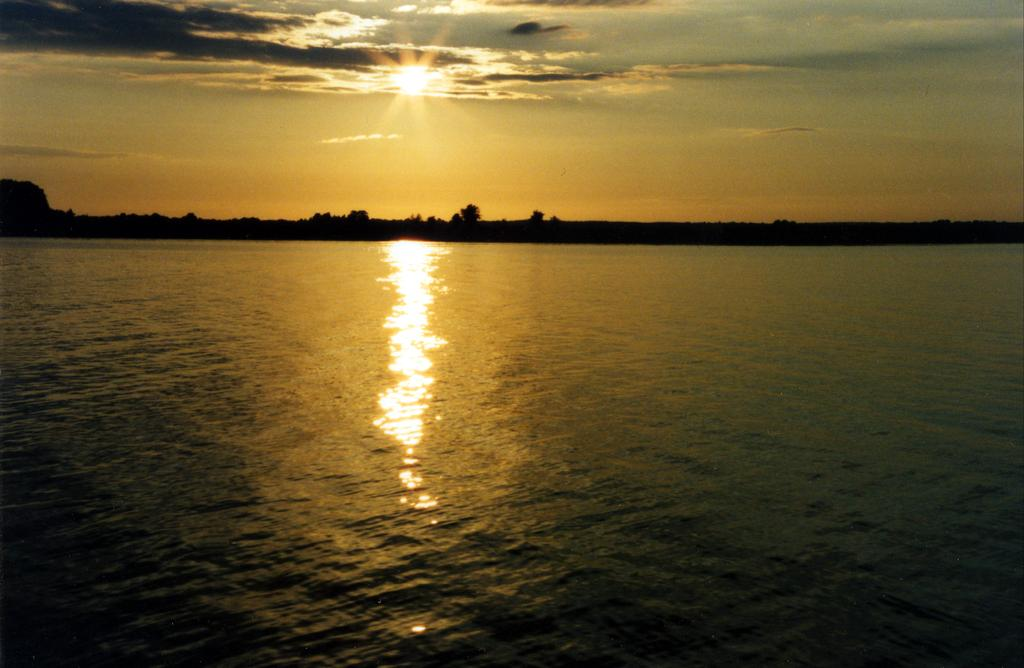What is the primary element visible in the image? There is water in the image. What can be seen in the background of the image? There are trees in the background of the image. What is visible at the top of the image? The sky is visible at the top of the image. What celestial body can be seen in the sky? The sun is present in the sky. What type of cloth is being used to make the argument in the image? There is no cloth or argument present in the image. What type of soda is being served in the image? There is no soda present in the image; it features water, trees, sky, and the sun. 